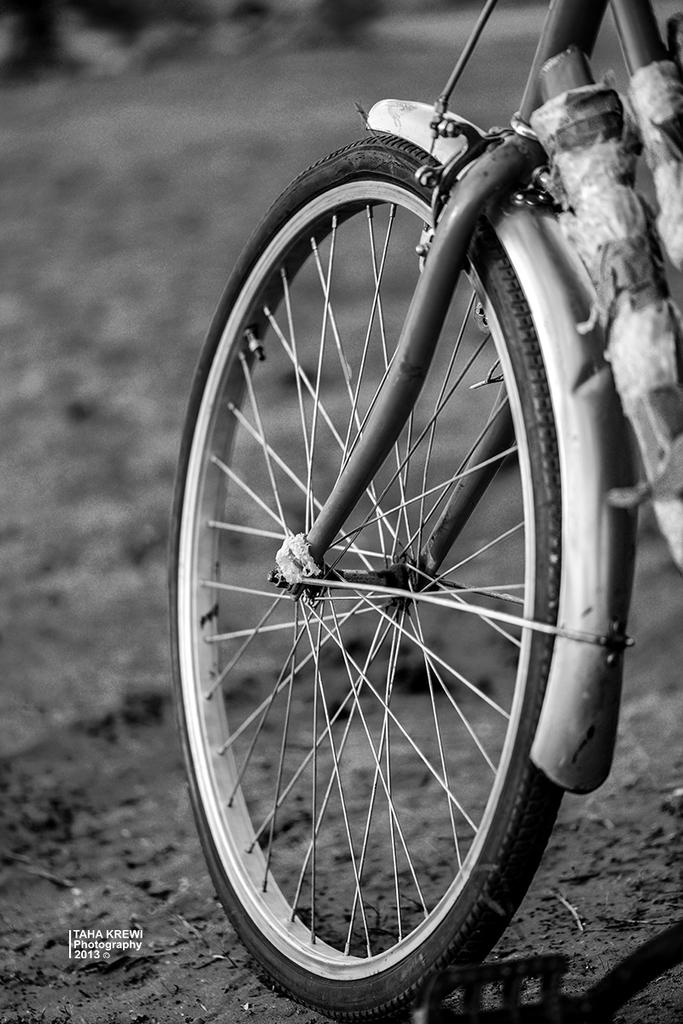What is the color scheme of the image? The image is black and white. What object can be seen in the image? There is a bicycle wheel in the image. What type of terrain is visible in the image? There is land visible in the image. Where is the text located in the image? The text is in the bottom left corner of the image. How many twigs are present in the image? There are no twigs visible in the image. What word is written in the text located in the bottom left corner of the image? The provided facts do not give information about the specific word or words in the text, so we cannot answer this question definitively. 